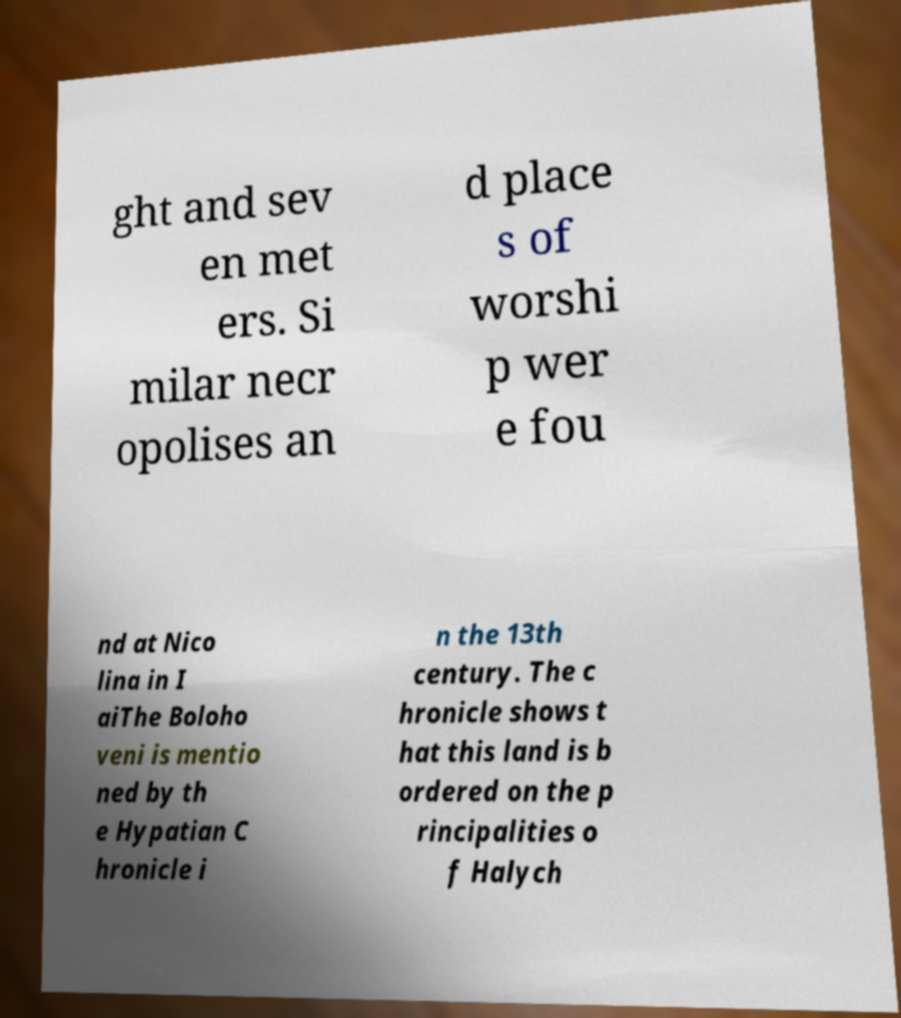Please read and relay the text visible in this image. What does it say? ght and sev en met ers. Si milar necr opolises an d place s of worshi p wer e fou nd at Nico lina in I aiThe Boloho veni is mentio ned by th e Hypatian C hronicle i n the 13th century. The c hronicle shows t hat this land is b ordered on the p rincipalities o f Halych 